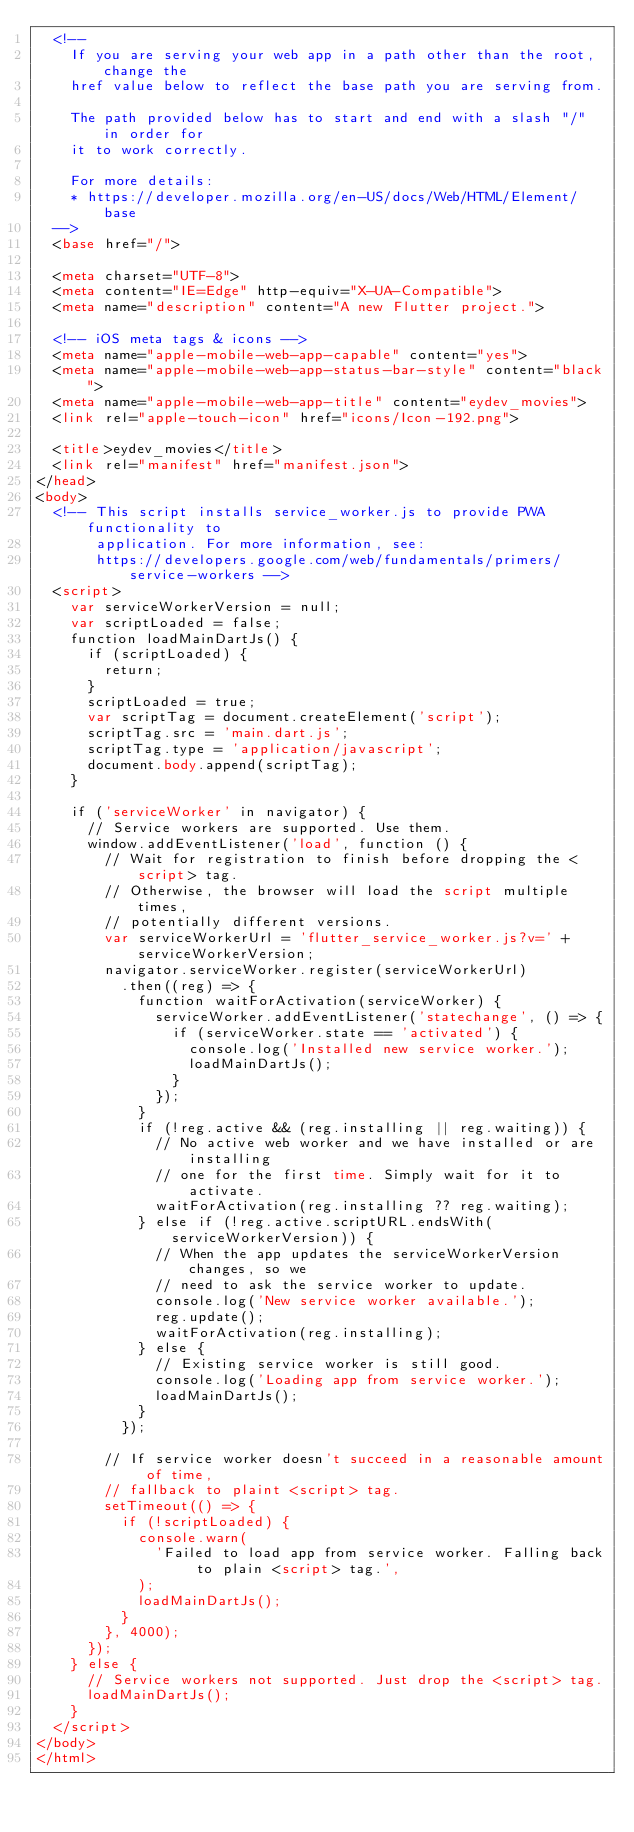<code> <loc_0><loc_0><loc_500><loc_500><_HTML_>  <!--
    If you are serving your web app in a path other than the root, change the
    href value below to reflect the base path you are serving from.

    The path provided below has to start and end with a slash "/" in order for
    it to work correctly.

    For more details:
    * https://developer.mozilla.org/en-US/docs/Web/HTML/Element/base
  -->
  <base href="/">

  <meta charset="UTF-8">
  <meta content="IE=Edge" http-equiv="X-UA-Compatible">
  <meta name="description" content="A new Flutter project.">

  <!-- iOS meta tags & icons -->
  <meta name="apple-mobile-web-app-capable" content="yes">
  <meta name="apple-mobile-web-app-status-bar-style" content="black">
  <meta name="apple-mobile-web-app-title" content="eydev_movies">
  <link rel="apple-touch-icon" href="icons/Icon-192.png">

  <title>eydev_movies</title>
  <link rel="manifest" href="manifest.json">
</head>
<body>
  <!-- This script installs service_worker.js to provide PWA functionality to
       application. For more information, see:
       https://developers.google.com/web/fundamentals/primers/service-workers -->
  <script>
    var serviceWorkerVersion = null;
    var scriptLoaded = false;
    function loadMainDartJs() {
      if (scriptLoaded) {
        return;
      }
      scriptLoaded = true;
      var scriptTag = document.createElement('script');
      scriptTag.src = 'main.dart.js';
      scriptTag.type = 'application/javascript';
      document.body.append(scriptTag);
    }

    if ('serviceWorker' in navigator) {
      // Service workers are supported. Use them.
      window.addEventListener('load', function () {
        // Wait for registration to finish before dropping the <script> tag.
        // Otherwise, the browser will load the script multiple times,
        // potentially different versions.
        var serviceWorkerUrl = 'flutter_service_worker.js?v=' + serviceWorkerVersion;
        navigator.serviceWorker.register(serviceWorkerUrl)
          .then((reg) => {
            function waitForActivation(serviceWorker) {
              serviceWorker.addEventListener('statechange', () => {
                if (serviceWorker.state == 'activated') {
                  console.log('Installed new service worker.');
                  loadMainDartJs();
                }
              });
            }
            if (!reg.active && (reg.installing || reg.waiting)) {
              // No active web worker and we have installed or are installing
              // one for the first time. Simply wait for it to activate.
              waitForActivation(reg.installing ?? reg.waiting);
            } else if (!reg.active.scriptURL.endsWith(serviceWorkerVersion)) {
              // When the app updates the serviceWorkerVersion changes, so we
              // need to ask the service worker to update.
              console.log('New service worker available.');
              reg.update();
              waitForActivation(reg.installing);
            } else {
              // Existing service worker is still good.
              console.log('Loading app from service worker.');
              loadMainDartJs();
            }
          });

        // If service worker doesn't succeed in a reasonable amount of time,
        // fallback to plaint <script> tag.
        setTimeout(() => {
          if (!scriptLoaded) {
            console.warn(
              'Failed to load app from service worker. Falling back to plain <script> tag.',
            );
            loadMainDartJs();
          }
        }, 4000);
      });
    } else {
      // Service workers not supported. Just drop the <script> tag.
      loadMainDartJs();
    }
  </script>
</body>
</html>
</code> 